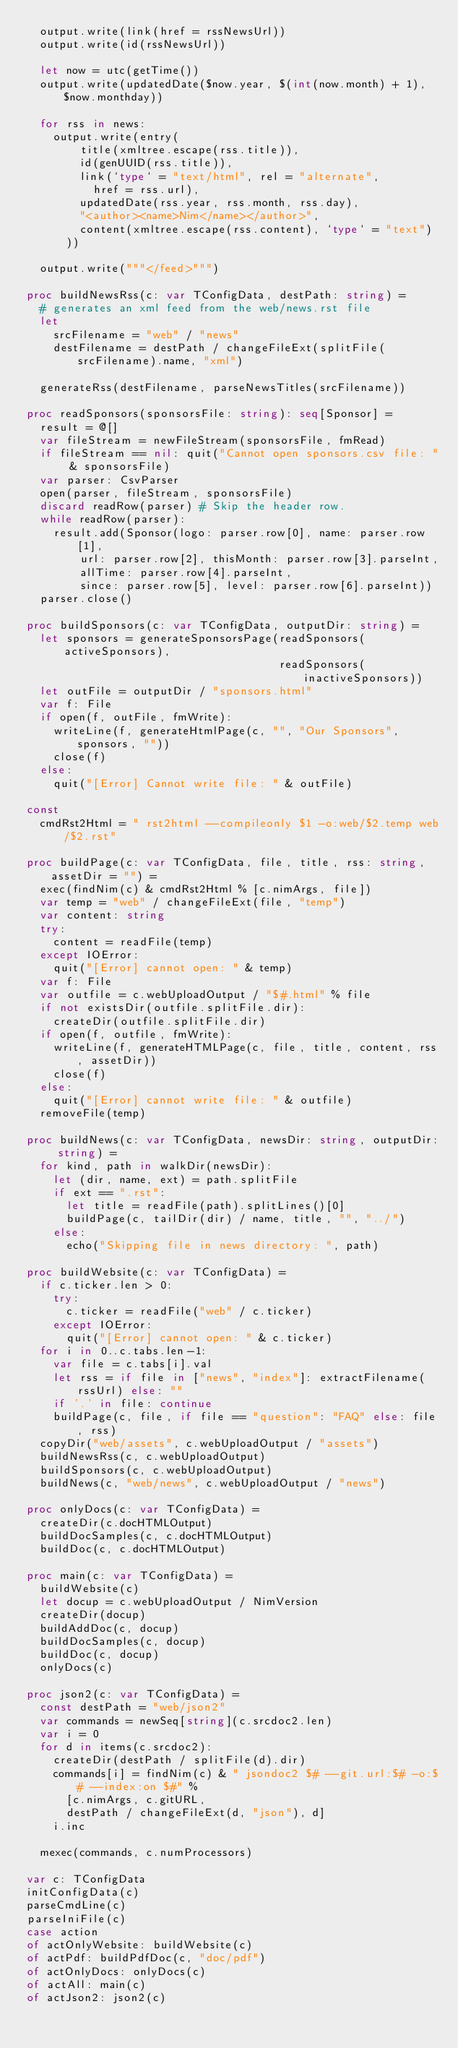Convert code to text. <code><loc_0><loc_0><loc_500><loc_500><_Nim_>  output.write(link(href = rssNewsUrl))
  output.write(id(rssNewsUrl))

  let now = utc(getTime())
  output.write(updatedDate($now.year, $(int(now.month) + 1), $now.monthday))

  for rss in news:
    output.write(entry(
        title(xmltree.escape(rss.title)),
        id(genUUID(rss.title)),
        link(`type` = "text/html", rel = "alternate",
          href = rss.url),
        updatedDate(rss.year, rss.month, rss.day),
        "<author><name>Nim</name></author>",
        content(xmltree.escape(rss.content), `type` = "text")
      ))

  output.write("""</feed>""")

proc buildNewsRss(c: var TConfigData, destPath: string) =
  # generates an xml feed from the web/news.rst file
  let
    srcFilename = "web" / "news"
    destFilename = destPath / changeFileExt(splitFile(srcFilename).name, "xml")

  generateRss(destFilename, parseNewsTitles(srcFilename))

proc readSponsors(sponsorsFile: string): seq[Sponsor] =
  result = @[]
  var fileStream = newFileStream(sponsorsFile, fmRead)
  if fileStream == nil: quit("Cannot open sponsors.csv file: " & sponsorsFile)
  var parser: CsvParser
  open(parser, fileStream, sponsorsFile)
  discard readRow(parser) # Skip the header row.
  while readRow(parser):
    result.add(Sponsor(logo: parser.row[0], name: parser.row[1],
        url: parser.row[2], thisMonth: parser.row[3].parseInt,
        allTime: parser.row[4].parseInt,
        since: parser.row[5], level: parser.row[6].parseInt))
  parser.close()

proc buildSponsors(c: var TConfigData, outputDir: string) =
  let sponsors = generateSponsorsPage(readSponsors(activeSponsors),
                                      readSponsors(inactiveSponsors))
  let outFile = outputDir / "sponsors.html"
  var f: File
  if open(f, outFile, fmWrite):
    writeLine(f, generateHtmlPage(c, "", "Our Sponsors", sponsors, ""))
    close(f)
  else:
    quit("[Error] Cannot write file: " & outFile)

const
  cmdRst2Html = " rst2html --compileonly $1 -o:web/$2.temp web/$2.rst"

proc buildPage(c: var TConfigData, file, title, rss: string, assetDir = "") =
  exec(findNim(c) & cmdRst2Html % [c.nimArgs, file])
  var temp = "web" / changeFileExt(file, "temp")
  var content: string
  try:
    content = readFile(temp)
  except IOError:
    quit("[Error] cannot open: " & temp)
  var f: File
  var outfile = c.webUploadOutput / "$#.html" % file
  if not existsDir(outfile.splitFile.dir):
    createDir(outfile.splitFile.dir)
  if open(f, outfile, fmWrite):
    writeLine(f, generateHTMLPage(c, file, title, content, rss, assetDir))
    close(f)
  else:
    quit("[Error] cannot write file: " & outfile)
  removeFile(temp)

proc buildNews(c: var TConfigData, newsDir: string, outputDir: string) =
  for kind, path in walkDir(newsDir):
    let (dir, name, ext) = path.splitFile
    if ext == ".rst":
      let title = readFile(path).splitLines()[0]
      buildPage(c, tailDir(dir) / name, title, "", "../")
    else:
      echo("Skipping file in news directory: ", path)

proc buildWebsite(c: var TConfigData) =
  if c.ticker.len > 0:
    try:
      c.ticker = readFile("web" / c.ticker)
    except IOError:
      quit("[Error] cannot open: " & c.ticker)
  for i in 0..c.tabs.len-1:
    var file = c.tabs[i].val
    let rss = if file in ["news", "index"]: extractFilename(rssUrl) else: ""
    if '.' in file: continue
    buildPage(c, file, if file == "question": "FAQ" else: file, rss)
  copyDir("web/assets", c.webUploadOutput / "assets")
  buildNewsRss(c, c.webUploadOutput)
  buildSponsors(c, c.webUploadOutput)
  buildNews(c, "web/news", c.webUploadOutput / "news")

proc onlyDocs(c: var TConfigData) =
  createDir(c.docHTMLOutput)
  buildDocSamples(c, c.docHTMLOutput)
  buildDoc(c, c.docHTMLOutput)

proc main(c: var TConfigData) =
  buildWebsite(c)
  let docup = c.webUploadOutput / NimVersion
  createDir(docup)
  buildAddDoc(c, docup)
  buildDocSamples(c, docup)
  buildDoc(c, docup)
  onlyDocs(c)

proc json2(c: var TConfigData) =
  const destPath = "web/json2"
  var commands = newSeq[string](c.srcdoc2.len)
  var i = 0
  for d in items(c.srcdoc2):
    createDir(destPath / splitFile(d).dir)
    commands[i] = findNim(c) & " jsondoc2 $# --git.url:$# -o:$# --index:on $#" %
      [c.nimArgs, c.gitURL,
      destPath / changeFileExt(d, "json"), d]
    i.inc

  mexec(commands, c.numProcessors)

var c: TConfigData
initConfigData(c)
parseCmdLine(c)
parseIniFile(c)
case action
of actOnlyWebsite: buildWebsite(c)
of actPdf: buildPdfDoc(c, "doc/pdf")
of actOnlyDocs: onlyDocs(c)
of actAll: main(c)
of actJson2: json2(c)
</code> 